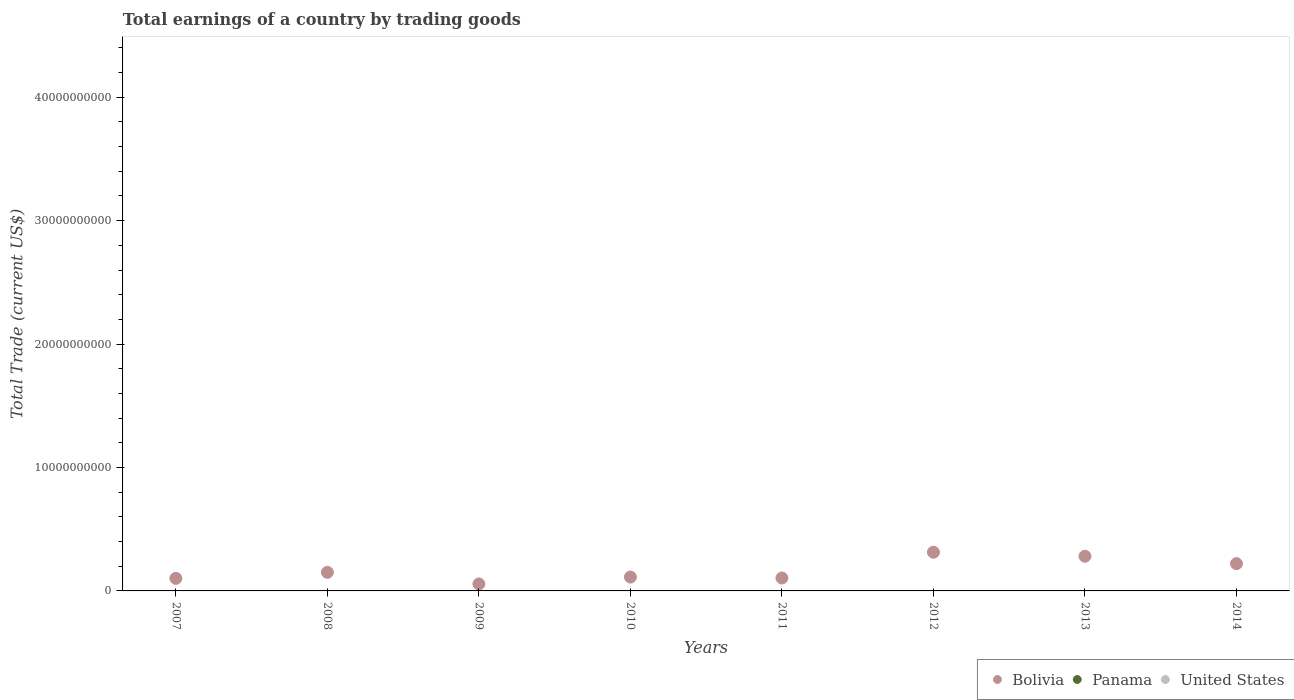How many different coloured dotlines are there?
Keep it short and to the point. 1. Is the number of dotlines equal to the number of legend labels?
Keep it short and to the point. No. Across all years, what is the maximum total earnings in Bolivia?
Offer a terse response. 3.14e+09. Across all years, what is the minimum total earnings in Bolivia?
Give a very brief answer. 5.66e+08. In which year was the total earnings in Bolivia maximum?
Ensure brevity in your answer.  2012. What is the difference between the total earnings in Bolivia in 2009 and that in 2012?
Give a very brief answer. -2.57e+09. What is the average total earnings in Bolivia per year?
Provide a short and direct response. 1.68e+09. What is the ratio of the total earnings in Bolivia in 2011 to that in 2013?
Your response must be concise. 0.37. What is the difference between the highest and the second highest total earnings in Bolivia?
Keep it short and to the point. 3.26e+08. What is the difference between the highest and the lowest total earnings in Bolivia?
Make the answer very short. 2.57e+09. Is it the case that in every year, the sum of the total earnings in Panama and total earnings in United States  is greater than the total earnings in Bolivia?
Offer a very short reply. No. Does the total earnings in Bolivia monotonically increase over the years?
Your response must be concise. No. Is the total earnings in United States strictly less than the total earnings in Bolivia over the years?
Offer a terse response. Yes. How many years are there in the graph?
Offer a very short reply. 8. What is the difference between two consecutive major ticks on the Y-axis?
Your answer should be compact. 1.00e+1. Are the values on the major ticks of Y-axis written in scientific E-notation?
Make the answer very short. No. Does the graph contain any zero values?
Your answer should be compact. Yes. How many legend labels are there?
Offer a terse response. 3. How are the legend labels stacked?
Provide a succinct answer. Horizontal. What is the title of the graph?
Ensure brevity in your answer.  Total earnings of a country by trading goods. What is the label or title of the Y-axis?
Provide a succinct answer. Total Trade (current US$). What is the Total Trade (current US$) in Bolivia in 2007?
Offer a very short reply. 1.02e+09. What is the Total Trade (current US$) of Panama in 2007?
Offer a very short reply. 0. What is the Total Trade (current US$) in United States in 2007?
Offer a terse response. 0. What is the Total Trade (current US$) of Bolivia in 2008?
Give a very brief answer. 1.51e+09. What is the Total Trade (current US$) in Panama in 2008?
Give a very brief answer. 0. What is the Total Trade (current US$) of United States in 2008?
Make the answer very short. 0. What is the Total Trade (current US$) of Bolivia in 2009?
Your answer should be very brief. 5.66e+08. What is the Total Trade (current US$) of Panama in 2009?
Offer a very short reply. 0. What is the Total Trade (current US$) of Bolivia in 2010?
Provide a succinct answer. 1.12e+09. What is the Total Trade (current US$) of Panama in 2010?
Your answer should be very brief. 0. What is the Total Trade (current US$) in Bolivia in 2011?
Ensure brevity in your answer.  1.05e+09. What is the Total Trade (current US$) of Panama in 2011?
Make the answer very short. 0. What is the Total Trade (current US$) in Bolivia in 2012?
Keep it short and to the point. 3.14e+09. What is the Total Trade (current US$) of Bolivia in 2013?
Offer a terse response. 2.81e+09. What is the Total Trade (current US$) of Panama in 2013?
Offer a terse response. 0. What is the Total Trade (current US$) of Bolivia in 2014?
Offer a very short reply. 2.21e+09. What is the Total Trade (current US$) in United States in 2014?
Keep it short and to the point. 0. Across all years, what is the maximum Total Trade (current US$) of Bolivia?
Offer a terse response. 3.14e+09. Across all years, what is the minimum Total Trade (current US$) in Bolivia?
Your answer should be very brief. 5.66e+08. What is the total Total Trade (current US$) of Bolivia in the graph?
Ensure brevity in your answer.  1.34e+1. What is the difference between the Total Trade (current US$) in Bolivia in 2007 and that in 2008?
Offer a terse response. -4.88e+08. What is the difference between the Total Trade (current US$) of Bolivia in 2007 and that in 2009?
Your response must be concise. 4.53e+08. What is the difference between the Total Trade (current US$) in Bolivia in 2007 and that in 2010?
Make the answer very short. -1.03e+08. What is the difference between the Total Trade (current US$) in Bolivia in 2007 and that in 2011?
Keep it short and to the point. -2.91e+07. What is the difference between the Total Trade (current US$) in Bolivia in 2007 and that in 2012?
Provide a short and direct response. -2.12e+09. What is the difference between the Total Trade (current US$) of Bolivia in 2007 and that in 2013?
Offer a terse response. -1.79e+09. What is the difference between the Total Trade (current US$) of Bolivia in 2007 and that in 2014?
Provide a short and direct response. -1.19e+09. What is the difference between the Total Trade (current US$) of Bolivia in 2008 and that in 2009?
Provide a succinct answer. 9.41e+08. What is the difference between the Total Trade (current US$) in Bolivia in 2008 and that in 2010?
Offer a very short reply. 3.85e+08. What is the difference between the Total Trade (current US$) in Bolivia in 2008 and that in 2011?
Provide a short and direct response. 4.59e+08. What is the difference between the Total Trade (current US$) of Bolivia in 2008 and that in 2012?
Offer a very short reply. -1.63e+09. What is the difference between the Total Trade (current US$) of Bolivia in 2008 and that in 2013?
Ensure brevity in your answer.  -1.30e+09. What is the difference between the Total Trade (current US$) in Bolivia in 2008 and that in 2014?
Give a very brief answer. -7.05e+08. What is the difference between the Total Trade (current US$) of Bolivia in 2009 and that in 2010?
Your answer should be compact. -5.56e+08. What is the difference between the Total Trade (current US$) in Bolivia in 2009 and that in 2011?
Keep it short and to the point. -4.82e+08. What is the difference between the Total Trade (current US$) in Bolivia in 2009 and that in 2012?
Offer a terse response. -2.57e+09. What is the difference between the Total Trade (current US$) in Bolivia in 2009 and that in 2013?
Make the answer very short. -2.24e+09. What is the difference between the Total Trade (current US$) of Bolivia in 2009 and that in 2014?
Keep it short and to the point. -1.65e+09. What is the difference between the Total Trade (current US$) of Bolivia in 2010 and that in 2011?
Keep it short and to the point. 7.41e+07. What is the difference between the Total Trade (current US$) of Bolivia in 2010 and that in 2012?
Provide a short and direct response. -2.01e+09. What is the difference between the Total Trade (current US$) in Bolivia in 2010 and that in 2013?
Offer a terse response. -1.69e+09. What is the difference between the Total Trade (current US$) in Bolivia in 2010 and that in 2014?
Provide a short and direct response. -1.09e+09. What is the difference between the Total Trade (current US$) in Bolivia in 2011 and that in 2012?
Provide a short and direct response. -2.09e+09. What is the difference between the Total Trade (current US$) in Bolivia in 2011 and that in 2013?
Ensure brevity in your answer.  -1.76e+09. What is the difference between the Total Trade (current US$) of Bolivia in 2011 and that in 2014?
Ensure brevity in your answer.  -1.16e+09. What is the difference between the Total Trade (current US$) in Bolivia in 2012 and that in 2013?
Make the answer very short. 3.26e+08. What is the difference between the Total Trade (current US$) in Bolivia in 2012 and that in 2014?
Offer a terse response. 9.23e+08. What is the difference between the Total Trade (current US$) in Bolivia in 2013 and that in 2014?
Keep it short and to the point. 5.97e+08. What is the average Total Trade (current US$) in Bolivia per year?
Your answer should be compact. 1.68e+09. What is the average Total Trade (current US$) of United States per year?
Make the answer very short. 0. What is the ratio of the Total Trade (current US$) in Bolivia in 2007 to that in 2008?
Keep it short and to the point. 0.68. What is the ratio of the Total Trade (current US$) of Bolivia in 2007 to that in 2009?
Offer a terse response. 1.8. What is the ratio of the Total Trade (current US$) of Bolivia in 2007 to that in 2010?
Ensure brevity in your answer.  0.91. What is the ratio of the Total Trade (current US$) of Bolivia in 2007 to that in 2011?
Make the answer very short. 0.97. What is the ratio of the Total Trade (current US$) of Bolivia in 2007 to that in 2012?
Your answer should be compact. 0.33. What is the ratio of the Total Trade (current US$) of Bolivia in 2007 to that in 2013?
Offer a very short reply. 0.36. What is the ratio of the Total Trade (current US$) of Bolivia in 2007 to that in 2014?
Offer a very short reply. 0.46. What is the ratio of the Total Trade (current US$) in Bolivia in 2008 to that in 2009?
Provide a succinct answer. 2.66. What is the ratio of the Total Trade (current US$) in Bolivia in 2008 to that in 2010?
Ensure brevity in your answer.  1.34. What is the ratio of the Total Trade (current US$) in Bolivia in 2008 to that in 2011?
Your response must be concise. 1.44. What is the ratio of the Total Trade (current US$) of Bolivia in 2008 to that in 2012?
Give a very brief answer. 0.48. What is the ratio of the Total Trade (current US$) in Bolivia in 2008 to that in 2013?
Offer a very short reply. 0.54. What is the ratio of the Total Trade (current US$) in Bolivia in 2008 to that in 2014?
Provide a short and direct response. 0.68. What is the ratio of the Total Trade (current US$) in Bolivia in 2009 to that in 2010?
Ensure brevity in your answer.  0.5. What is the ratio of the Total Trade (current US$) of Bolivia in 2009 to that in 2011?
Give a very brief answer. 0.54. What is the ratio of the Total Trade (current US$) in Bolivia in 2009 to that in 2012?
Ensure brevity in your answer.  0.18. What is the ratio of the Total Trade (current US$) of Bolivia in 2009 to that in 2013?
Give a very brief answer. 0.2. What is the ratio of the Total Trade (current US$) in Bolivia in 2009 to that in 2014?
Provide a short and direct response. 0.26. What is the ratio of the Total Trade (current US$) in Bolivia in 2010 to that in 2011?
Make the answer very short. 1.07. What is the ratio of the Total Trade (current US$) in Bolivia in 2010 to that in 2012?
Ensure brevity in your answer.  0.36. What is the ratio of the Total Trade (current US$) of Bolivia in 2010 to that in 2013?
Your answer should be compact. 0.4. What is the ratio of the Total Trade (current US$) in Bolivia in 2010 to that in 2014?
Give a very brief answer. 0.51. What is the ratio of the Total Trade (current US$) in Bolivia in 2011 to that in 2012?
Provide a short and direct response. 0.33. What is the ratio of the Total Trade (current US$) of Bolivia in 2011 to that in 2013?
Keep it short and to the point. 0.37. What is the ratio of the Total Trade (current US$) in Bolivia in 2011 to that in 2014?
Offer a very short reply. 0.47. What is the ratio of the Total Trade (current US$) in Bolivia in 2012 to that in 2013?
Make the answer very short. 1.12. What is the ratio of the Total Trade (current US$) of Bolivia in 2012 to that in 2014?
Make the answer very short. 1.42. What is the ratio of the Total Trade (current US$) of Bolivia in 2013 to that in 2014?
Provide a succinct answer. 1.27. What is the difference between the highest and the second highest Total Trade (current US$) in Bolivia?
Provide a short and direct response. 3.26e+08. What is the difference between the highest and the lowest Total Trade (current US$) in Bolivia?
Keep it short and to the point. 2.57e+09. 